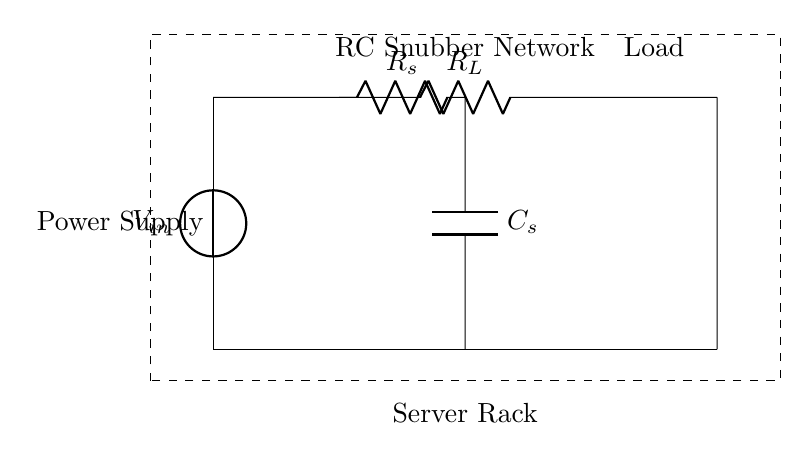What components are in the RC snubber network? The snubber network consists of a resistor labeled R_s and a capacitor labeled C_s.
Answer: R_s and C_s What is the purpose of the RC snubber network in this circuit? The RC snubber network is used to suppress voltage transients and protect the power supply components from potential overvoltage conditions.
Answer: To suppress voltage transients Where is the load connected in relation to the power supply? The load, indicated by R_L, is connected to the output side of the power supply, after the RC snubber network.
Answer: After the RC snubber network What type of circuit configuration is indicated by the presence of both a resistor and capacitor? The configuration described is a Resistor-Capacitor (RC) circuit, typically used for filtering signals and managing transient responses.
Answer: RC circuit How does the placement of the snubber network affect the overall circuit operation? The snubber network, placed between the power supply and the load, helps to reduce ringing and suppress noise, leading to improved reliability of the circuit.
Answer: Reduces ringing and suppresses noise 